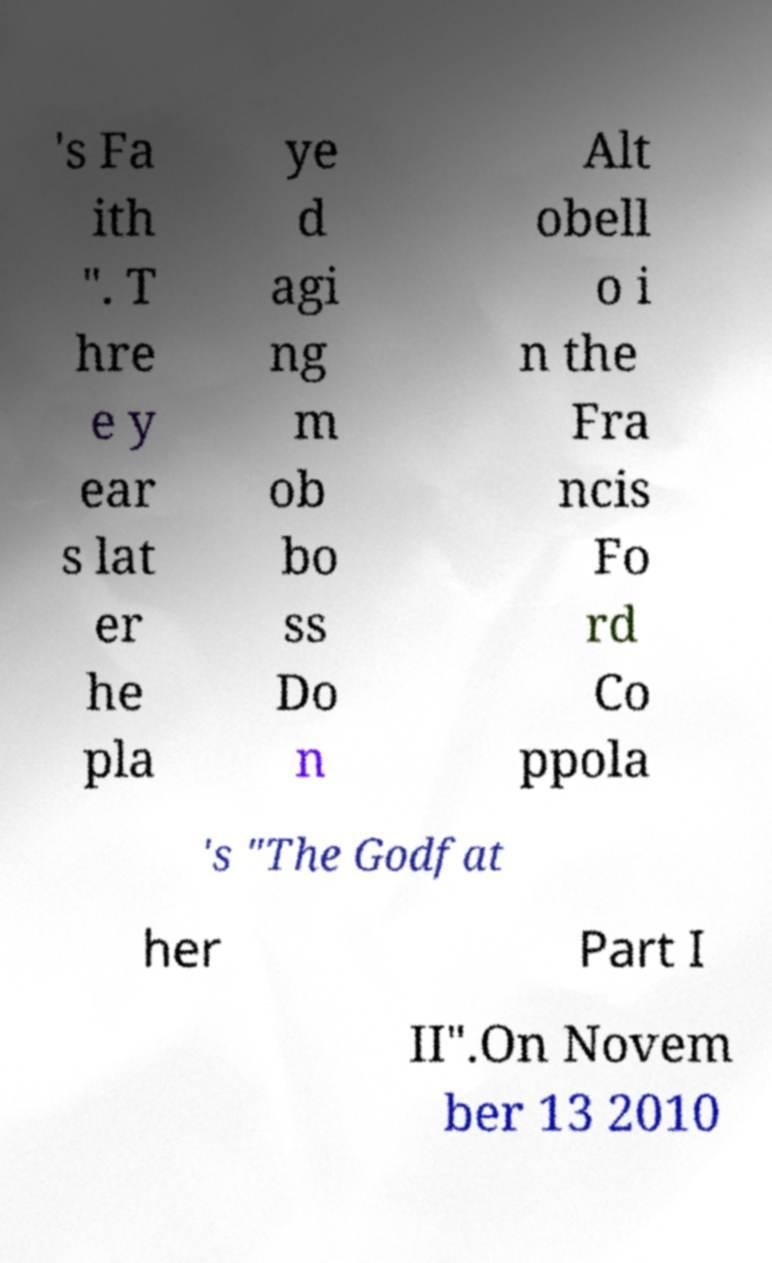There's text embedded in this image that I need extracted. Can you transcribe it verbatim? 's Fa ith ". T hre e y ear s lat er he pla ye d agi ng m ob bo ss Do n Alt obell o i n the Fra ncis Fo rd Co ppola 's "The Godfat her Part I II".On Novem ber 13 2010 